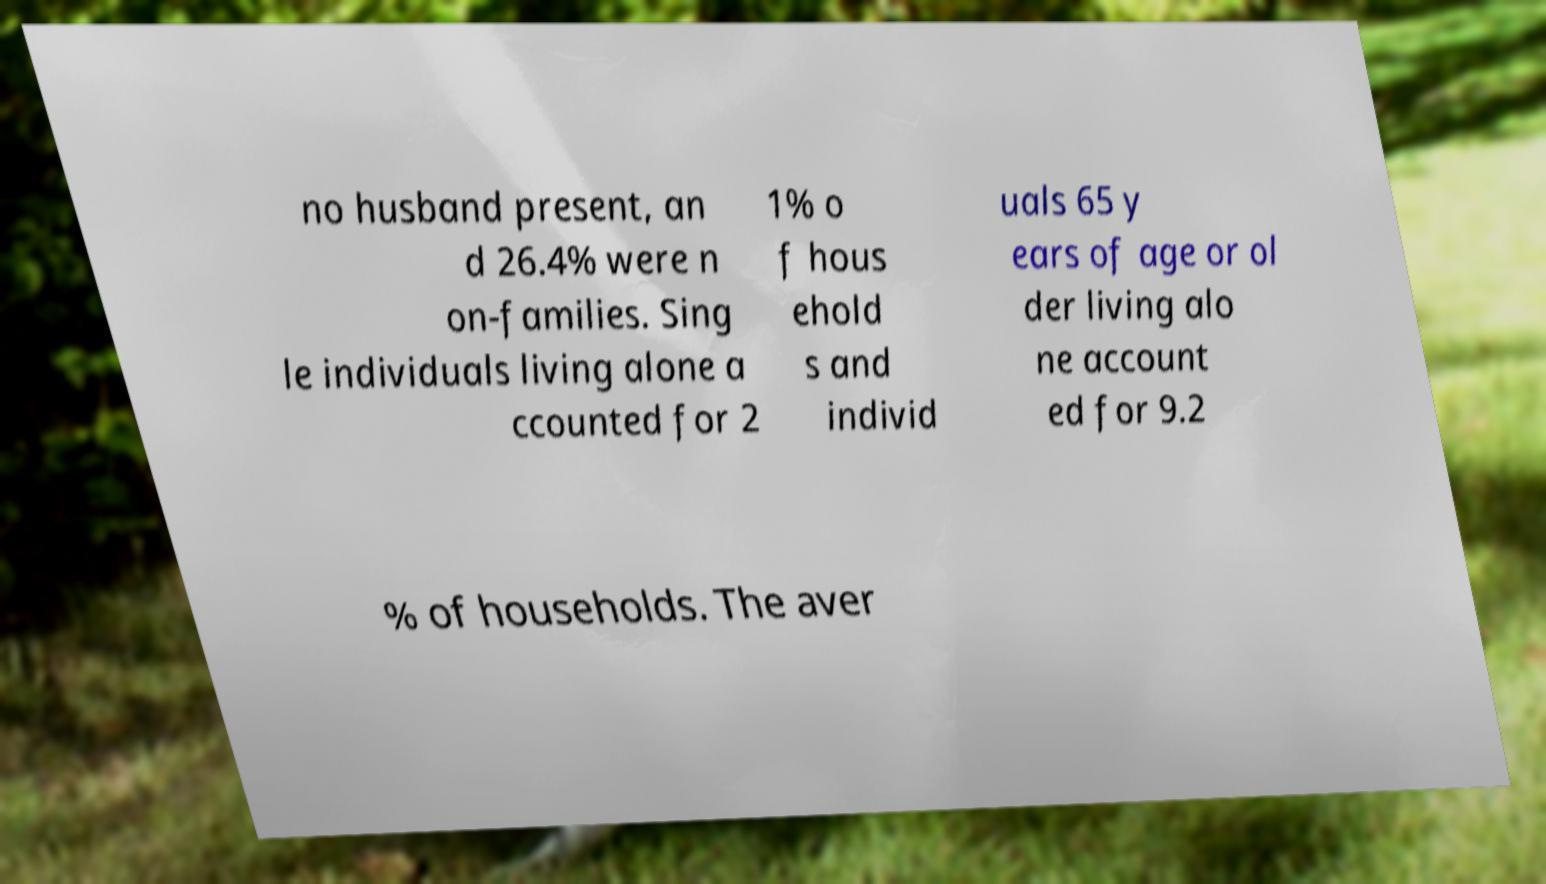There's text embedded in this image that I need extracted. Can you transcribe it verbatim? no husband present, an d 26.4% were n on-families. Sing le individuals living alone a ccounted for 2 1% o f hous ehold s and individ uals 65 y ears of age or ol der living alo ne account ed for 9.2 % of households. The aver 